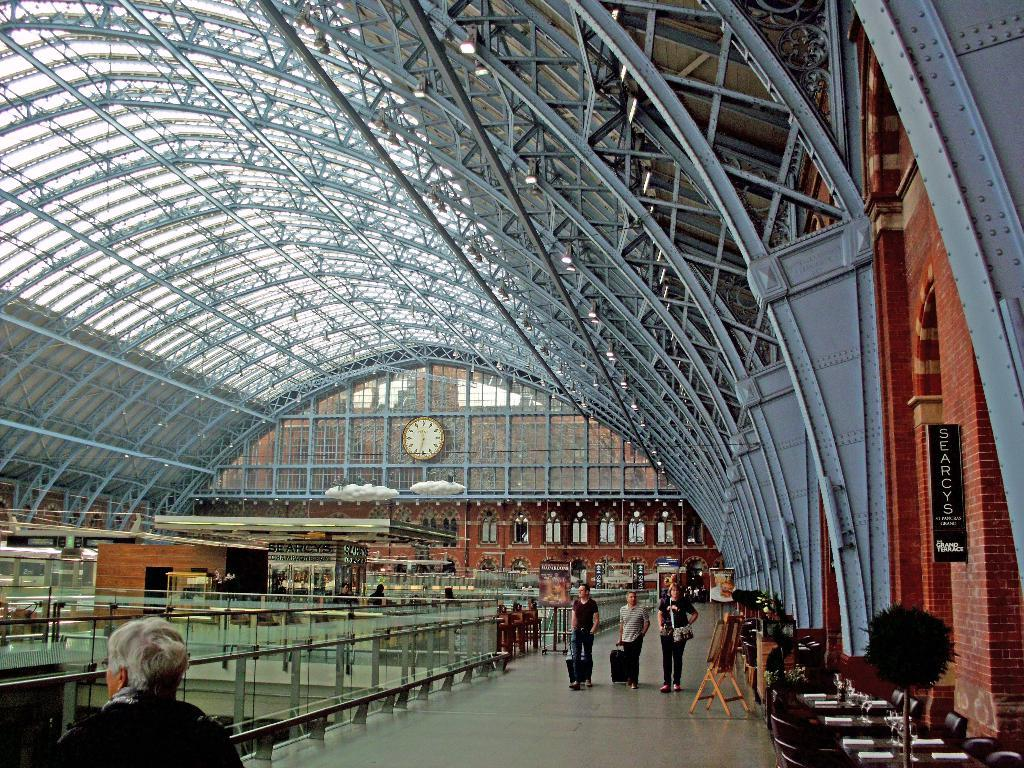What are the people in the image doing? The people in the image are walking on the floor. What type of roof is present above the floor? The floor has an iron roof. What objects can be seen related to art or creativity? There are painting boards visible in the image. What time-related object can be seen on a building in the image? There is a big clock on a building in the image. How many pages are visible in the image? There are no pages present in the image. What type of crowd can be seen gathering around the clock in the image? There is no crowd visible in the image; only the big clock on a building is mentioned. 